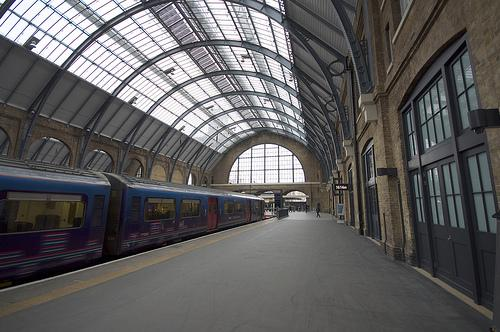What is the predominant color of the doors and windows in the train station? The doors are brown with many windows, and windows have brown trim. Identify and count the different types of objects present in the image. 4 train car objects, 8 window objects, 5 train visible objects, 1 telephone booth, 1 person wearing black, 1 group of people, 1 black door, 1 subway train, 1 cement walkway, 1 set of windows with brown trim, 1 arch dome of windows, 1 set of brown doors, 1 gray loading platform, 1 yellow caution line, 1 sign, 1 person, 1 brick wall, and 1 set of long windows. Analyze the interaction between the passengers and the trains in the picture. People are walking around and standing near the trains, which indicates they may be preparing to board or have recently disembarked. Mention some activities happening in the background of this image. Lots of people walking, a person wearing black standing, and a person walking in the background. In this image, can you provide a brief description of the scene taking place at a transportation facility? A busy train station with various colorful trains, many people walking, a long and empty platform, and a ceiling with an open skylight. What kind of flooring can be observed near the train? A cement walkway in the subway and a gray loading platform with a yellow caution line. Evaluate the atmosphere of the image using your observations. The atmosphere appears bustling and energetic, with various train cars and many people walking throughout the train station. What interesting architectural feature is visible on the wall in the image? The wall is made of brick. What type of vehicles can be seen in the image? Colorful train cars, blue subway train, and two blue and purple subway trains. Briefly describe the architecture of the ceiling shown in the image. The ceiling features an open skylight with an arch dome of windows and lots of light shining through. Is there a red train car located at X:0 Y:161 with a width of 110 and height of 110? The train car mentioned in the provided information is colorful, not specifically red. A misleading instruction would imply that it is red. Is there a person wearing a blue jacket standing at X:313 Y:193 with a width of 13 and height of 13? The person mentioned in the provided information is wearing black, not blue. The instruction would be misleading if it stated the person is wearing a blue jacket. Can you find a circular window at the end of the terminal with X:237 Y:169, width: 15, and height: 15? The window given in the information is not mentioned to be circular. This instruction is misleading as it adds an incorrect attribute to the available information. Are the doors with windows at X:428 Y:150 having a width of 55 and height of 55, surrounded by a purple frame? The information provided about the doors with windows does not mention any purple frame. Adding this attribute to the instruction would be misleading. Does the loading platform for the train have a green color at X:1 Y:200 with width 490 and height 490? The loading platform mentioned in the provided information is gray, not green. It would be misleading to ask if it's green. Is there a telephone booth at X:333 Y:182 with a width of 50 and height of 50? The provided telephone booth dimensions are width 17 and height 17. This instruction is misleading as it provides incorrect size information about the telephone booth. 